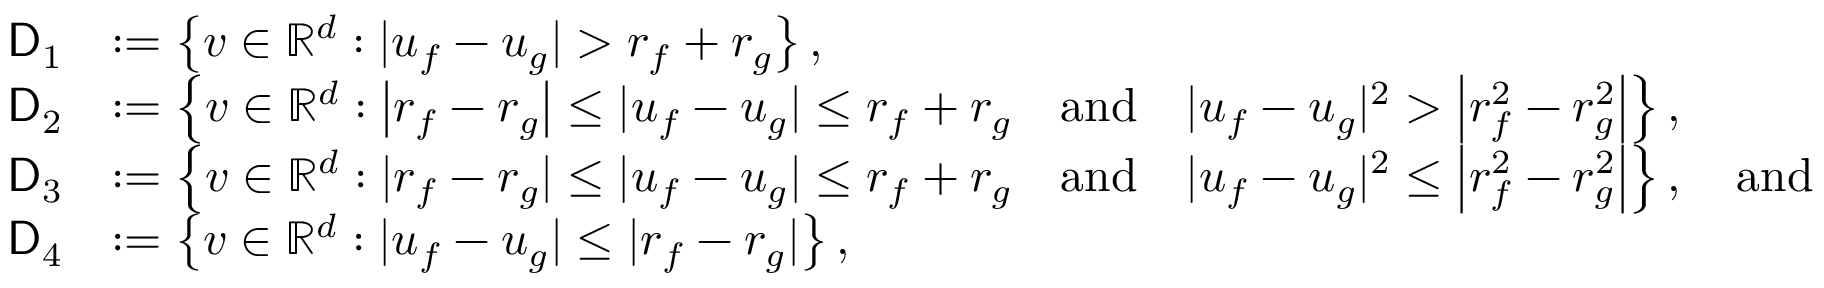Convert formula to latex. <formula><loc_0><loc_0><loc_500><loc_500>\begin{array} { r l } { D _ { 1 } } & { \colon = \left \{ v \in \mathbb { R } ^ { d } \colon | u _ { f } - u _ { g } | > r _ { f } + r _ { g } \right \} , } \\ { D _ { 2 } } & { \colon = \left \{ v \in \mathbb { R } ^ { d } \colon \left | r _ { f } - r _ { g } \right | \leq | u _ { f } - u _ { g } | \leq r _ { f } + r _ { g } \quad a n d \quad | u _ { f } - u _ { g } | ^ { 2 } > \left | r _ { f } ^ { 2 } - r _ { g } ^ { 2 } \right | \right \} , } \\ { D _ { 3 } } & { \colon = \left \{ v \in \mathbb { R } ^ { d } \colon | r _ { f } - r _ { g } | \leq | u _ { f } - u _ { g } | \leq r _ { f } + r _ { g } \quad a n d \quad | u _ { f } - u _ { g } | ^ { 2 } \leq \left | r _ { f } ^ { 2 } - r _ { g } ^ { 2 } \right | \right \} , \quad a n d } \\ { D _ { 4 } } & { \colon = \left \{ v \in \mathbb { R } ^ { d } \colon | u _ { f } - u _ { g } | \leq | r _ { f } - r _ { g } | \right \} , } \end{array}</formula> 